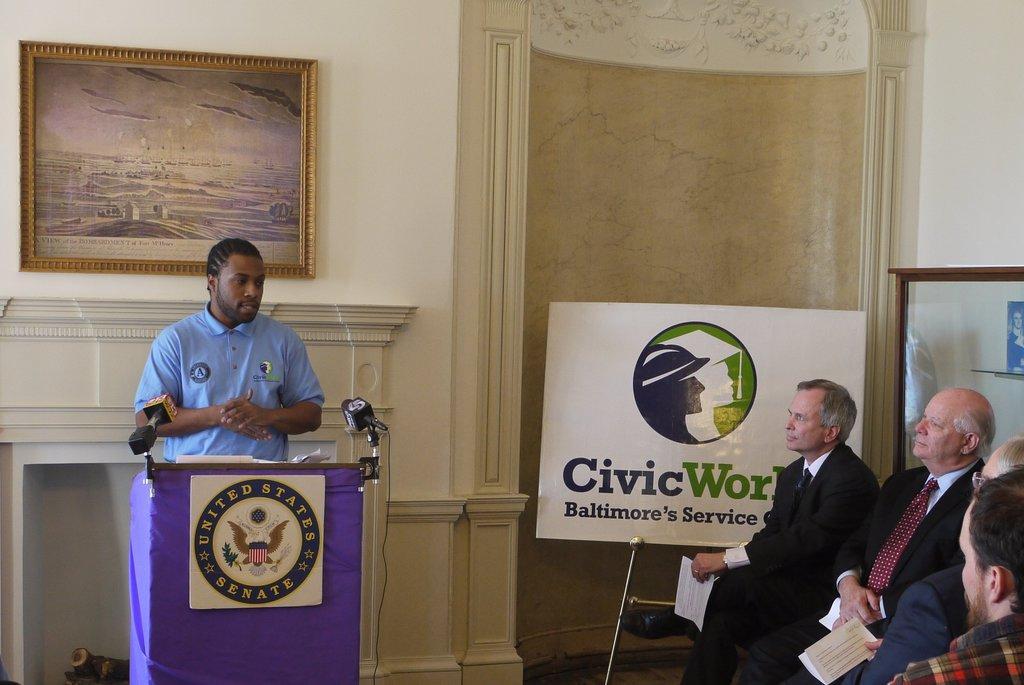Please provide a concise description of this image. On the left side a man is standing near the podium and speaking, he wore blue color shirt. Behind him there is a photo frame on the wall, on the right side few men are sitting, they wore coats, ties, shirts and trousers. 